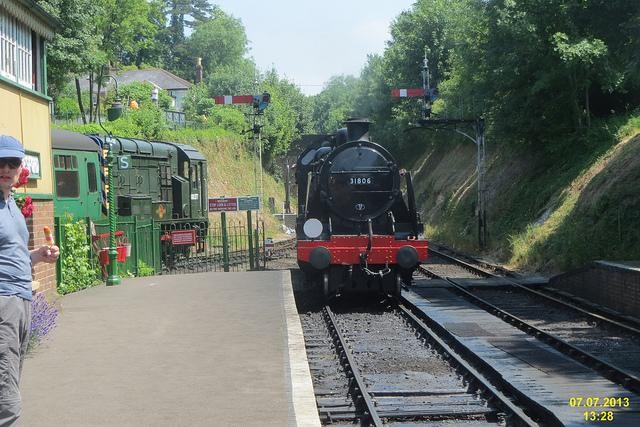What sound do people say the item on the right makes? Please explain your reasoning. choo choo. The train says choo choo. 